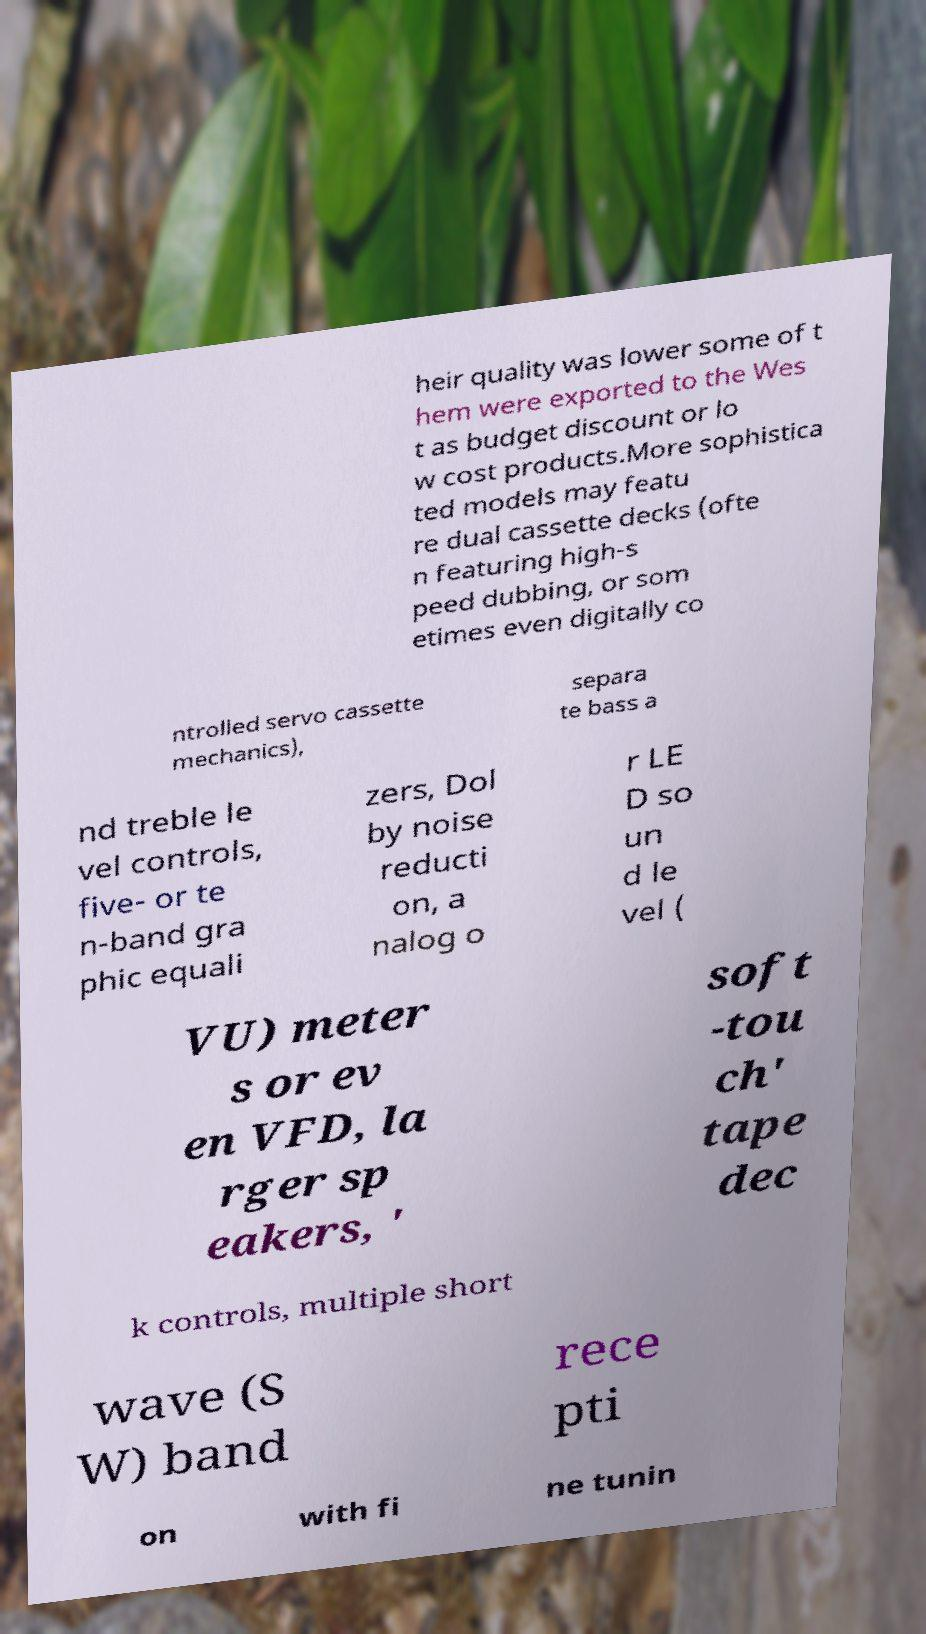For documentation purposes, I need the text within this image transcribed. Could you provide that? heir quality was lower some of t hem were exported to the Wes t as budget discount or lo w cost products.More sophistica ted models may featu re dual cassette decks (ofte n featuring high-s peed dubbing, or som etimes even digitally co ntrolled servo cassette mechanics), separa te bass a nd treble le vel controls, five- or te n-band gra phic equali zers, Dol by noise reducti on, a nalog o r LE D so un d le vel ( VU) meter s or ev en VFD, la rger sp eakers, ' soft -tou ch' tape dec k controls, multiple short wave (S W) band rece pti on with fi ne tunin 